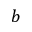<formula> <loc_0><loc_0><loc_500><loc_500>b</formula> 